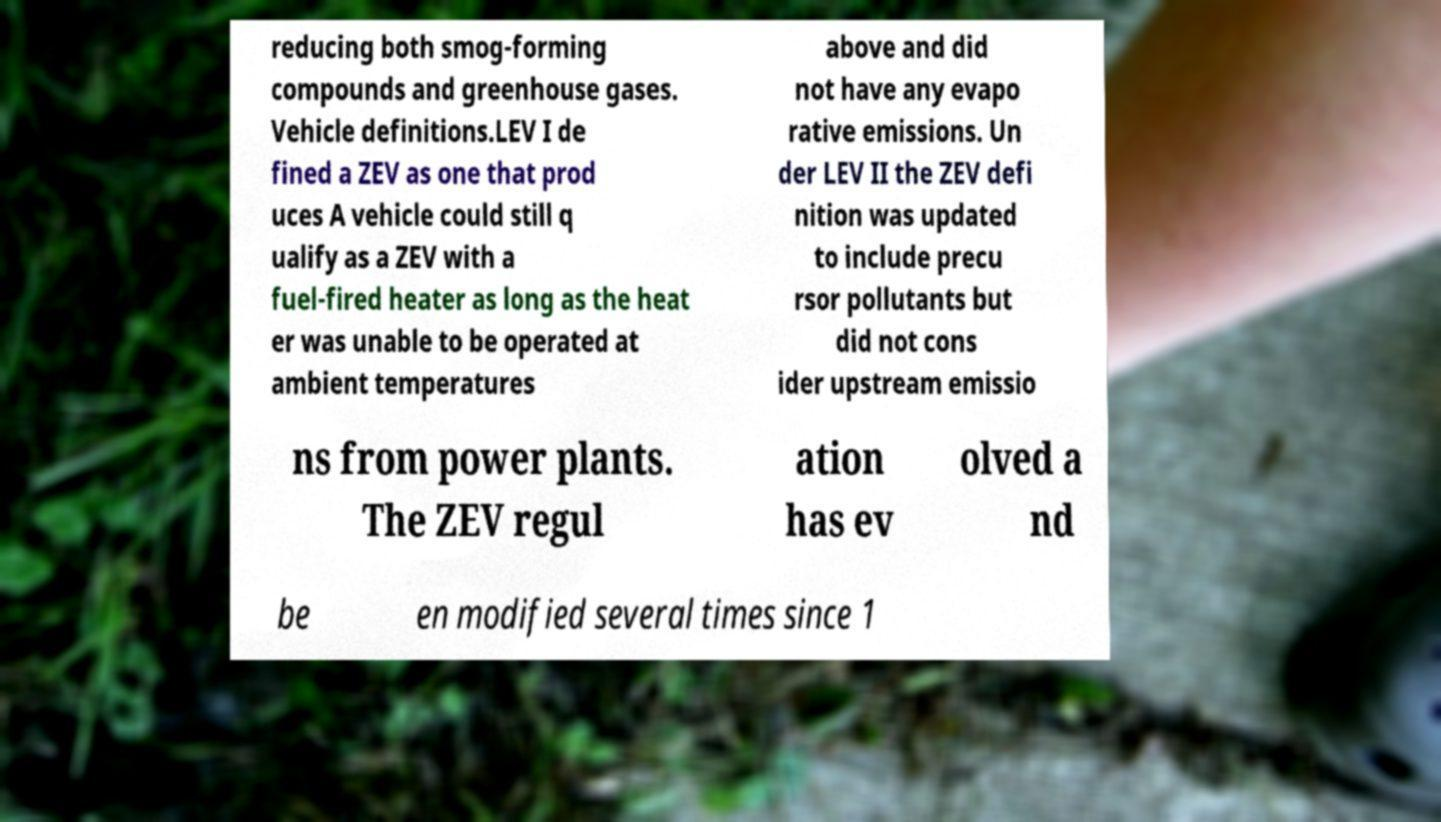Can you accurately transcribe the text from the provided image for me? reducing both smog-forming compounds and greenhouse gases. Vehicle definitions.LEV I de fined a ZEV as one that prod uces A vehicle could still q ualify as a ZEV with a fuel-fired heater as long as the heat er was unable to be operated at ambient temperatures above and did not have any evapo rative emissions. Un der LEV II the ZEV defi nition was updated to include precu rsor pollutants but did not cons ider upstream emissio ns from power plants. The ZEV regul ation has ev olved a nd be en modified several times since 1 